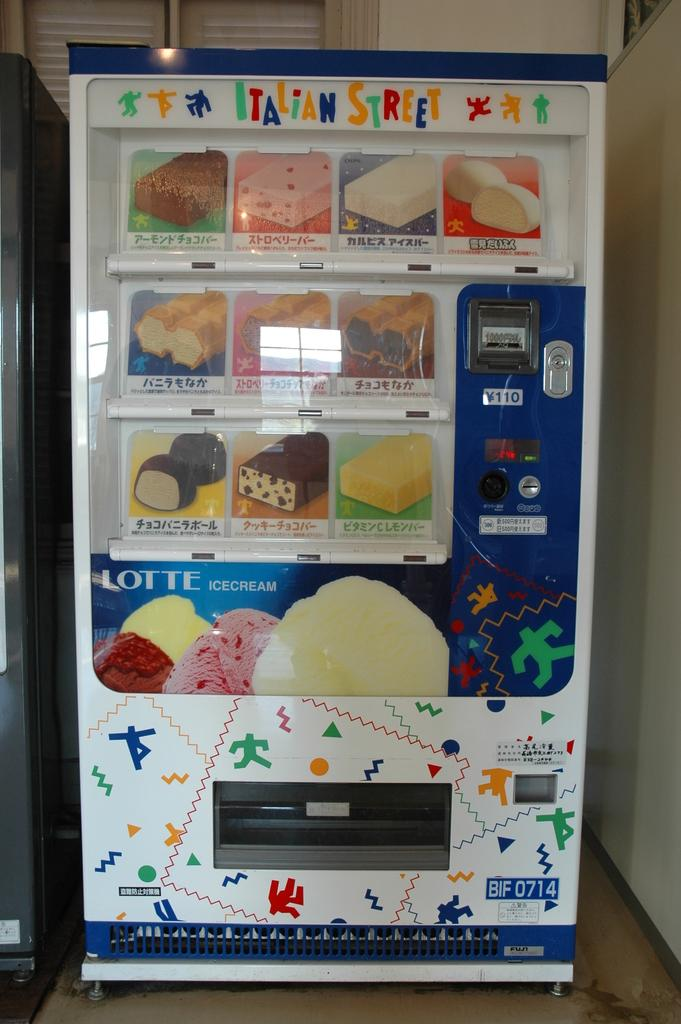<image>
Relay a brief, clear account of the picture shown. an italian street vending machine that sells ice cream 